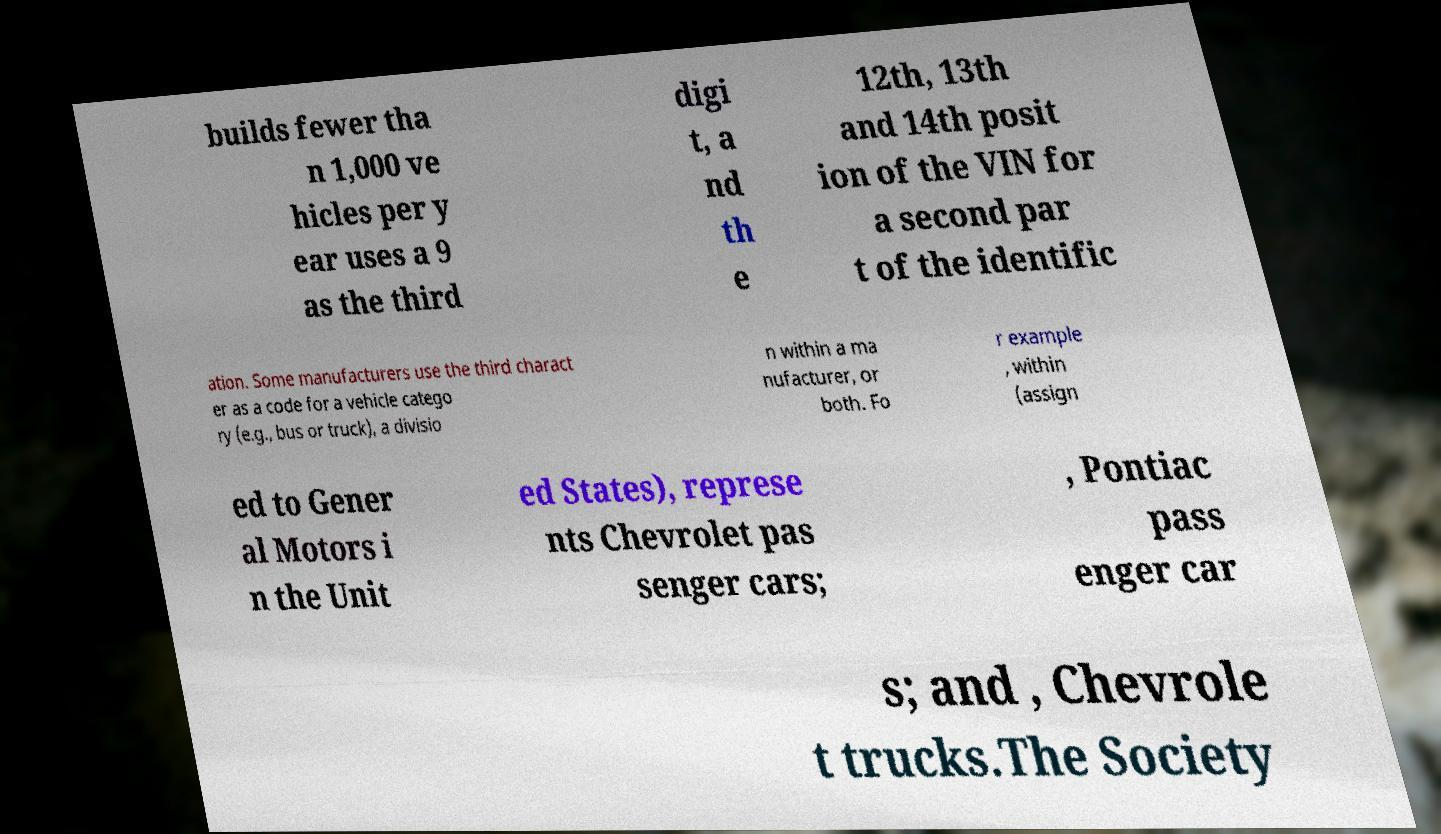What messages or text are displayed in this image? I need them in a readable, typed format. builds fewer tha n 1,000 ve hicles per y ear uses a 9 as the third digi t, a nd th e 12th, 13th and 14th posit ion of the VIN for a second par t of the identific ation. Some manufacturers use the third charact er as a code for a vehicle catego ry (e.g., bus or truck), a divisio n within a ma nufacturer, or both. Fo r example , within (assign ed to Gener al Motors i n the Unit ed States), represe nts Chevrolet pas senger cars; , Pontiac pass enger car s; and , Chevrole t trucks.The Society 